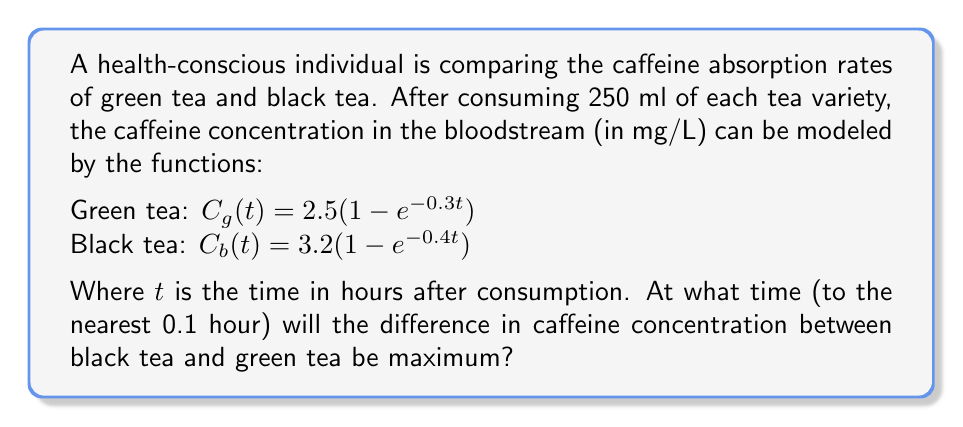Could you help me with this problem? To solve this problem, we need to follow these steps:

1) The difference in caffeine concentration is given by:
   $D(t) = C_b(t) - C_g(t) = 3.2(1 - e^{-0.4t}) - 2.5(1 - e^{-0.3t})$

2) To find the maximum difference, we need to find where the derivative of $D(t)$ equals zero:
   $D'(t) = 3.2(0.4e^{-0.4t}) - 2.5(0.3e^{-0.3t}) = 1.28e^{-0.4t} - 0.75e^{-0.3t}$

3) Set $D'(t) = 0$:
   $1.28e^{-0.4t} - 0.75e^{-0.3t} = 0$

4) Rearrange the equation:
   $1.28e^{-0.4t} = 0.75e^{-0.3t}$

5) Take the natural log of both sides:
   $\ln(1.28) - 0.4t = \ln(0.75) - 0.3t$

6) Solve for $t$:
   $0.2472 - 0.4t = -0.2877 - 0.3t$
   $0.2472 + 0.2877 = 0.4t - 0.3t$
   $0.5349 = 0.1t$
   $t = 5.349$ hours

7) Rounding to the nearest 0.1 hour:
   $t \approx 5.3$ hours
Answer: 5.3 hours 